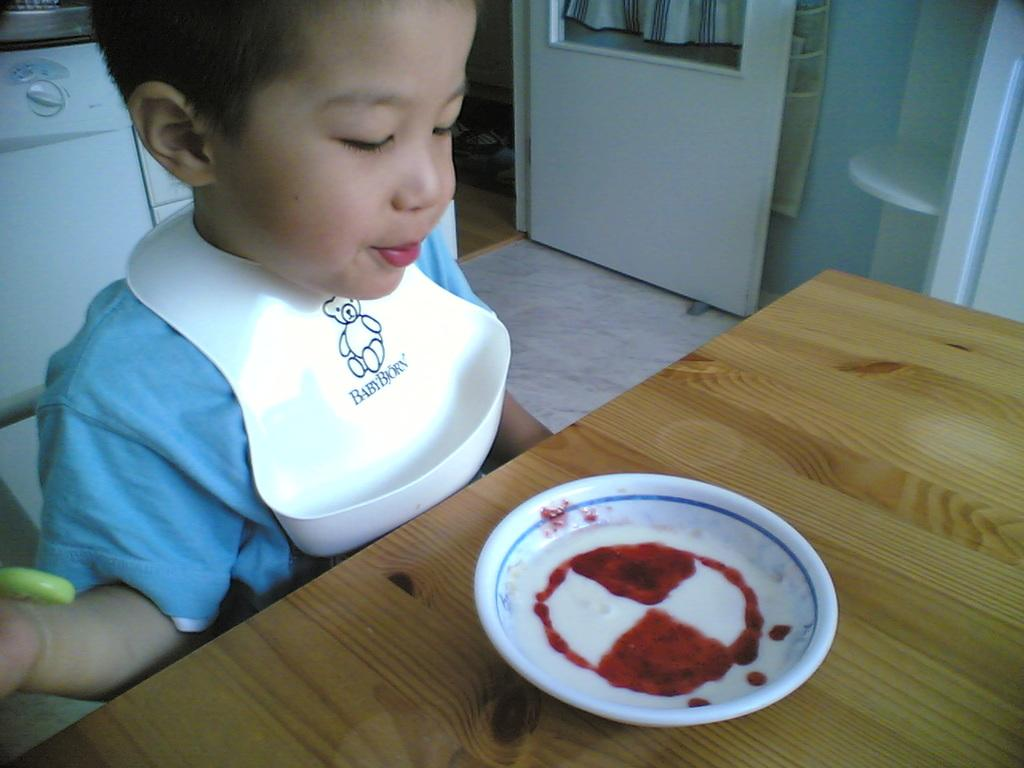Who is the main subject in the image? There is a boy in the image. What is the boy doing in the image? The boy is sitting in front of a table. What is on the table in the image? There is a plate with food on the table. What can be seen behind the boy in the image? There is a machine visible behind the boy. Where is the door located in the image? There is a door in the image, located between the wall. What type of rhythm can be heard coming from the picture in the image? There is no picture present in the image, and therefore no rhythm can be heard. 